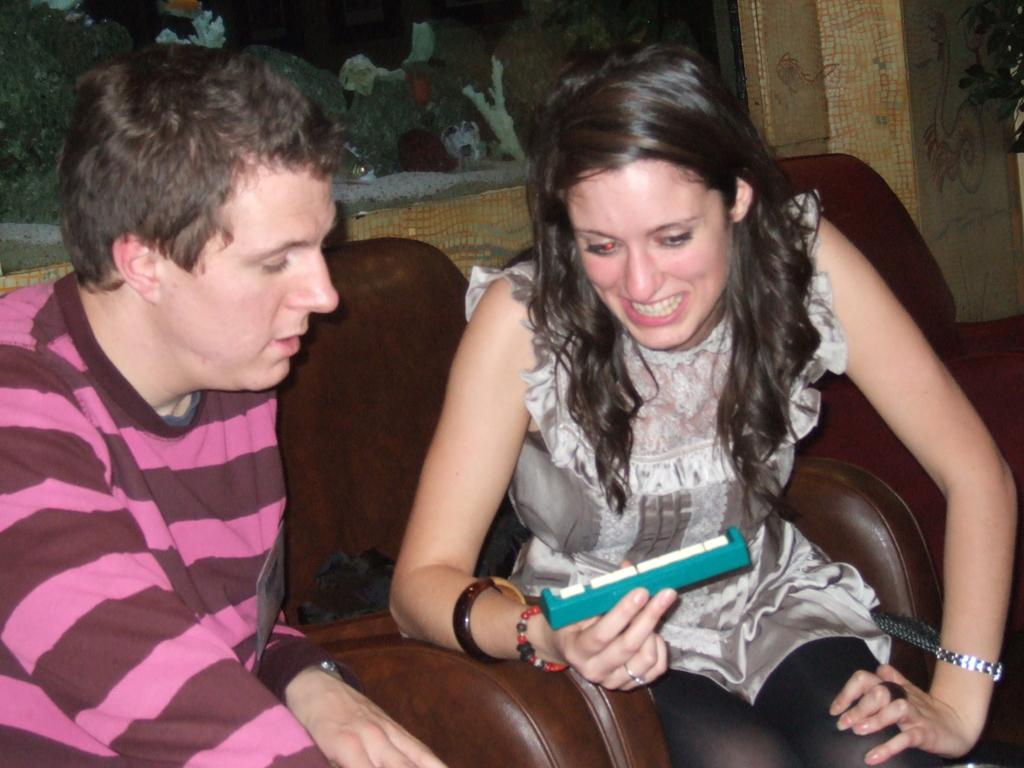How many people are sitting on the couch in the image? There are two people sitting on the couch in the image. What is one person doing while sitting on the couch? One person is holding something. What can be seen on the wall in the background of the image? There is a frame on the wall in the background of the image. What type of fang is visible on the person sitting on the couch? There is no fang visible on the person sitting on the couch in the image. 